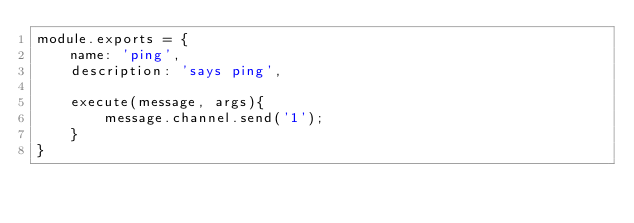Convert code to text. <code><loc_0><loc_0><loc_500><loc_500><_JavaScript_>module.exports = {
    name: 'ping',
    description: 'says ping',

    execute(message, args){
        message.channel.send('1');
    }
}</code> 